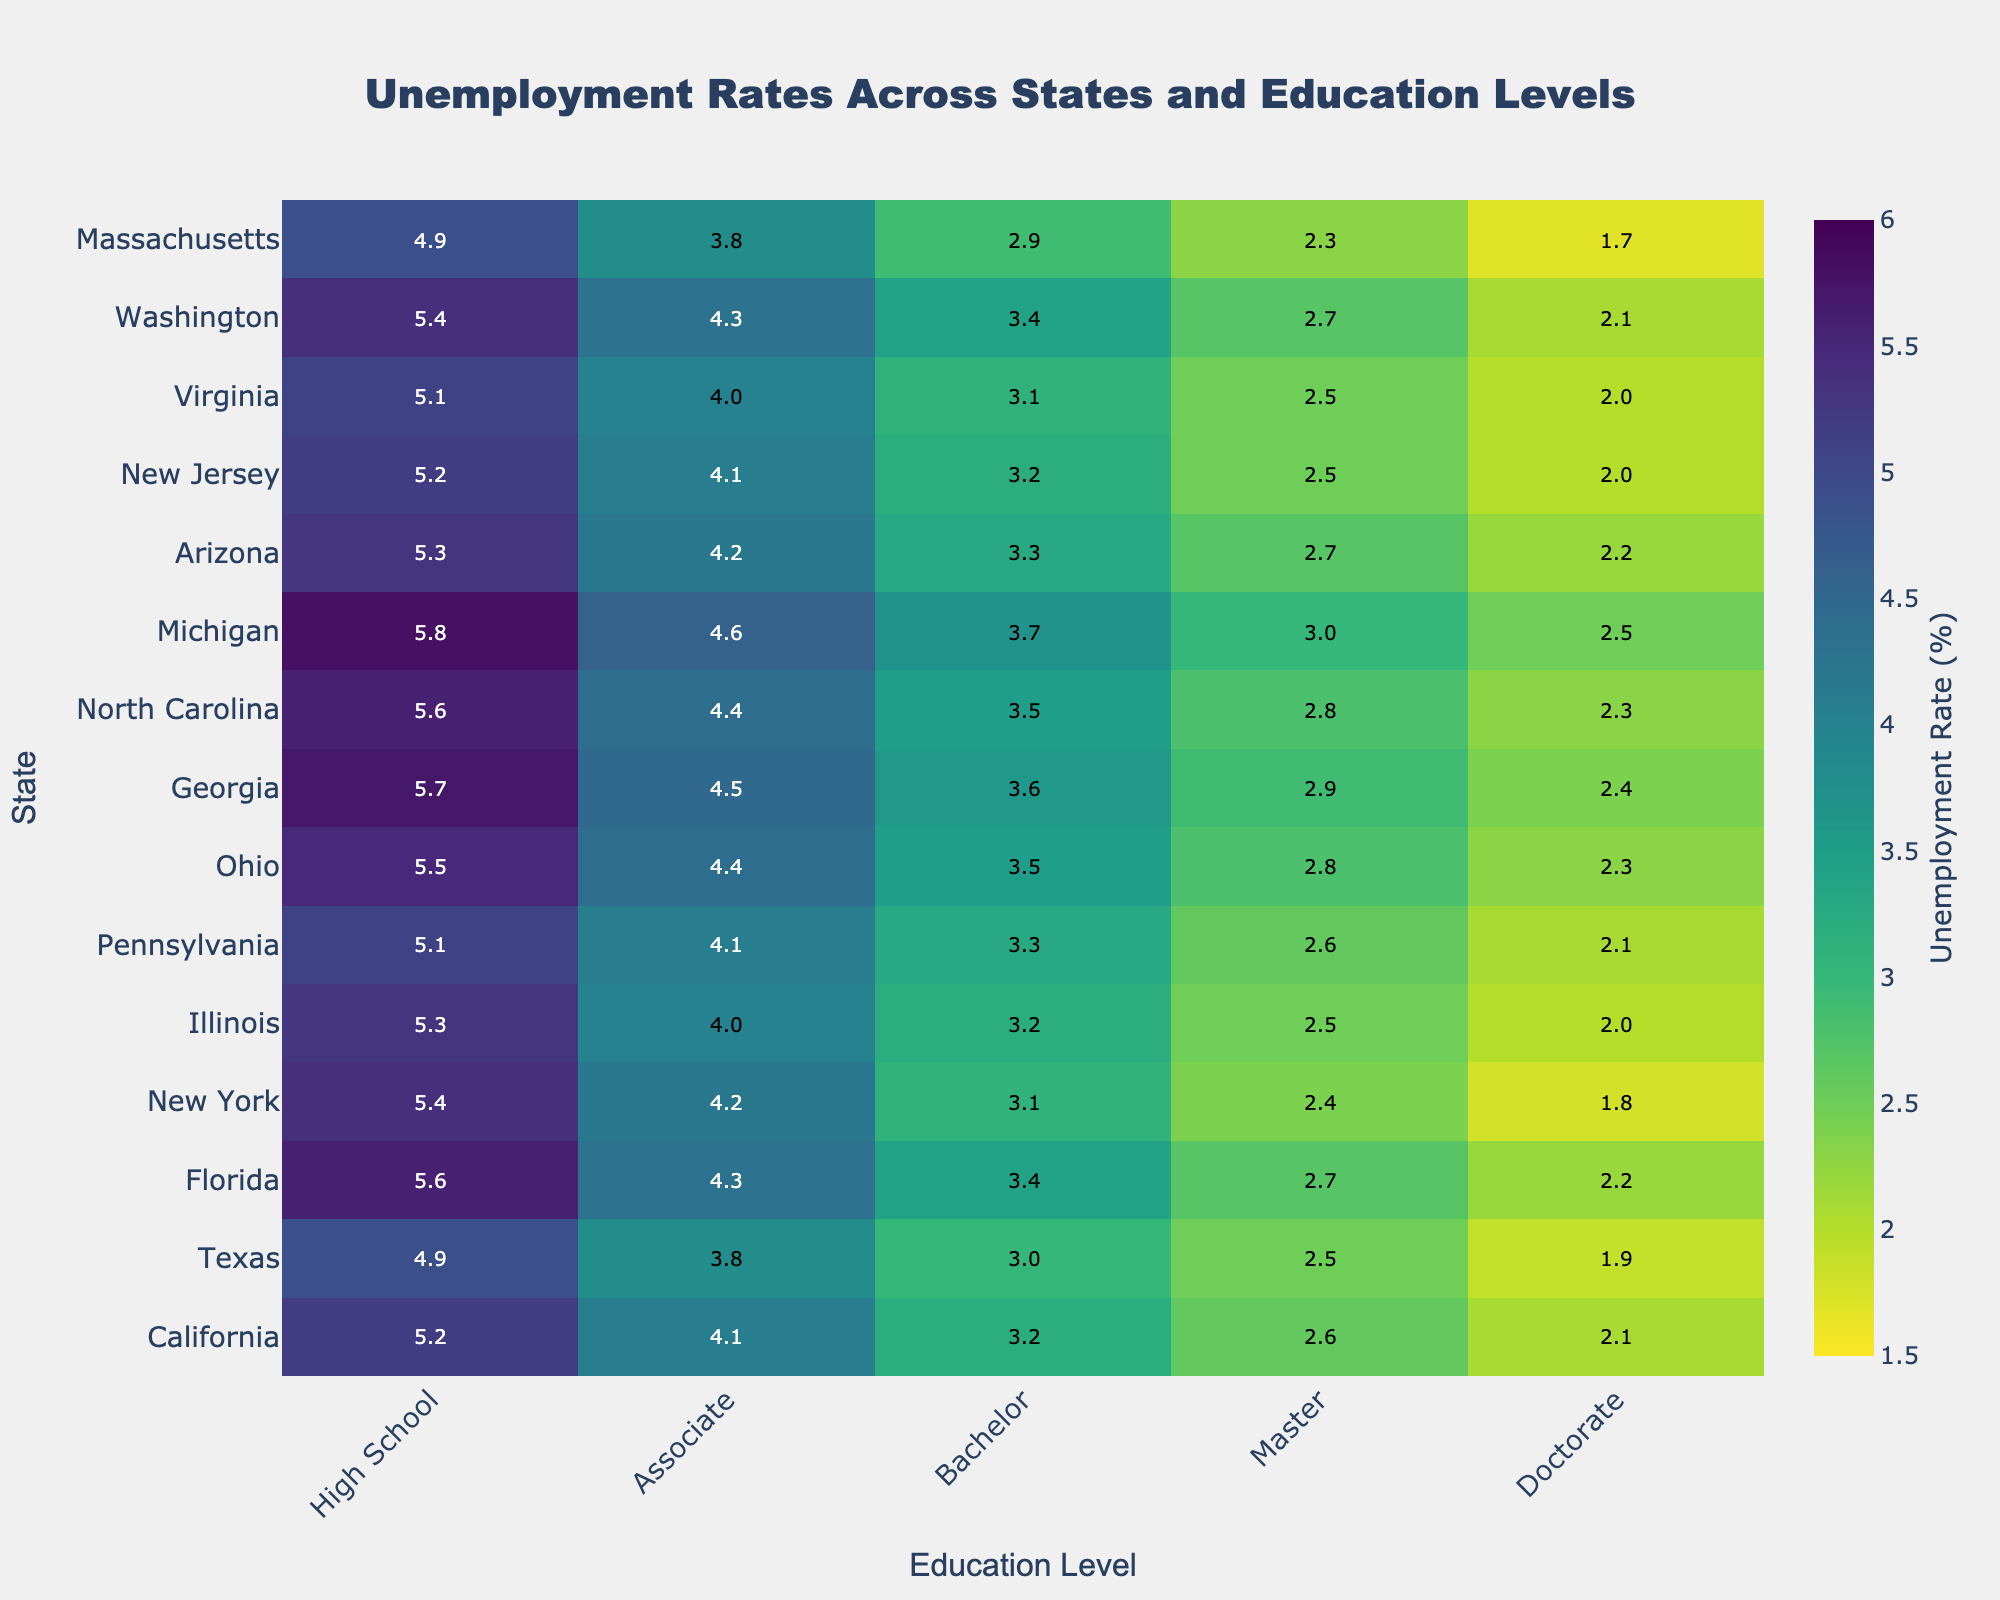What's the title of the heatmap? The title is located at the top of the chart, indicating the main subject of the figure. In this case, it reads "Unemployment Rates Across States and Education Levels".
Answer: Unemployment Rates Across States and Education Levels Which state has the lowest unemployment rate for individuals with a Doctorate degree? Look for the column corresponding to Doctorate and identify the smallest value within that column. Massachusetts has the lowest value, 1.7%.
Answer: Massachusetts How does the unemployment rate for individuals with a Bachelor’s degree compare between California and Florida? Locate the row for California and find the value under the Bachelor column, then do the same for Florida. Compare the two values (California: 3.2%, Florida: 3.4%). California's rate is lower.
Answer: California's rate is lower What's the average unemployment rate for New York across all educational levels? Find the row for New York, sum up the unemployment rates across all educational levels (5.4 + 4.2 + 3.1 + 2.4 + 1.8 = 16.9), and then divide by the number of educational levels (5). The average is 16.9/5 = 3.38%.
Answer: 3.38% Which educational level generally shows the highest unemployment rates across most states? Scan horizontally across the heatmap and compare the values for each educational level. High School consistently shows the highest rates in most states.
Answer: High School What's the difference in unemployment rate between individuals with an Associate degree and those with a Master’s degree in Ohio? Locate the row for Ohio and note the unemployment rates for Associate (4.4%) and Master’s degrees (2.8%). Subtract the Master’s rate from the Associate rate (4.4 - 2.8 = 1.6%).
Answer: 1.6% Which state shows the greatest variance in unemployment rates across different educational levels? Calculate the range (maximum value - minimum value) for each state and identify the state with the largest range. Michigan has the greatest variance (5.8 - 2.5 = 3.3%).
Answer: Michigan In which state do individuals with a Master's degree have the lowest unemployment rate? Scan the column for Master’s degree and identify the smallest value across all states. Massachusetts has the lowest rate at 2.3%.
Answer: Massachusetts How does the unemployment rate for individuals with a Bachelor’s degree in Washington compare to the same rate in Illinois? Look at the Bachelor’s degree column and compare the rates for Washington (3.4%) and Illinois (3.2%). Washington's rate is higher.
Answer: Washington's rate is higher What is the color of the section representing the unemployment rate of 4.5% for individuals with an Associate degree in Georgia? Find the intersection of Georgia and Associate degree (4.5%). The color of the corresponding cell would reflect this rate, likely a shade on the "Viridis" scale close to other 4.5% values. Visual inspection is required for precision.
Answer: Shade on the "Viridis" scale 